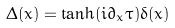<formula> <loc_0><loc_0><loc_500><loc_500>\Delta ( x ) = \tanh ( i \partial _ { x } \tau ) \delta ( x )</formula> 